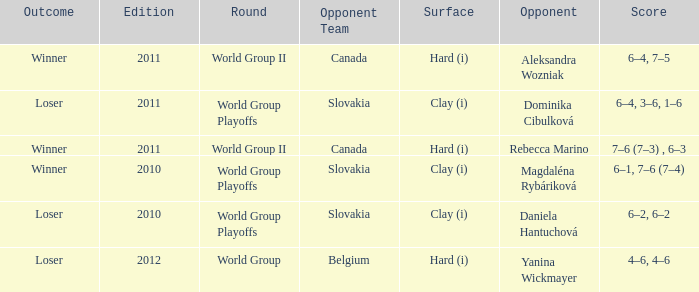What was the score when the opposing team was from Belgium? 4–6, 4–6. 